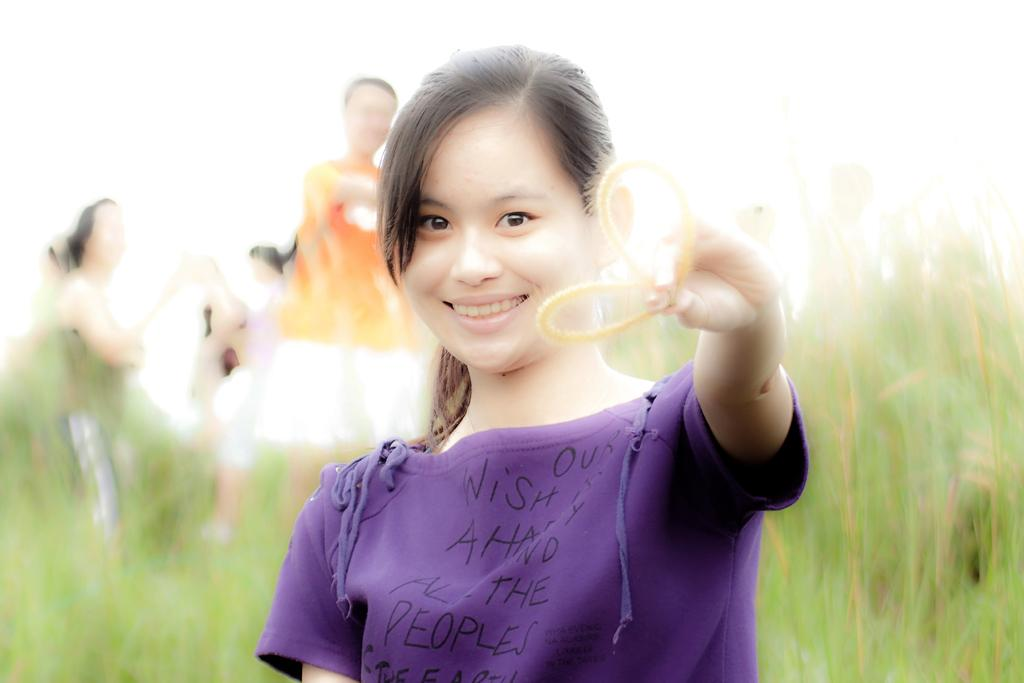What is the girl in the image holding? The girl is holding an object in the image. What can be seen in the background or surrounding the girl? There are plants visible in the image. Are there any other people present in the image? Yes, there are other people present in the image. How many dogs are present in the image, and what are they doing? There are no dogs present in the image. 